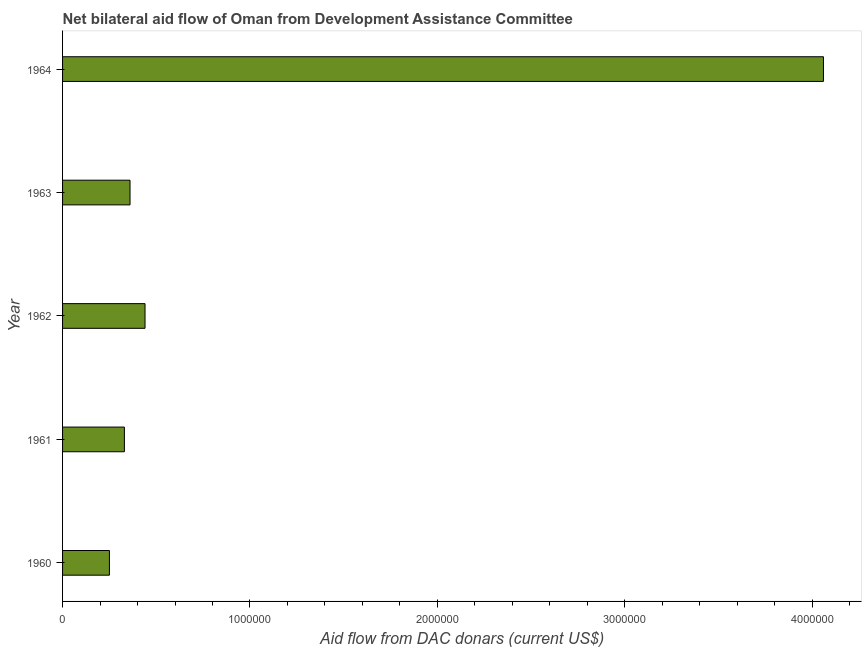Does the graph contain grids?
Provide a short and direct response. No. What is the title of the graph?
Offer a terse response. Net bilateral aid flow of Oman from Development Assistance Committee. What is the label or title of the X-axis?
Keep it short and to the point. Aid flow from DAC donars (current US$). What is the net bilateral aid flows from dac donors in 1964?
Your response must be concise. 4.06e+06. Across all years, what is the maximum net bilateral aid flows from dac donors?
Ensure brevity in your answer.  4.06e+06. In which year was the net bilateral aid flows from dac donors maximum?
Give a very brief answer. 1964. In which year was the net bilateral aid flows from dac donors minimum?
Give a very brief answer. 1960. What is the sum of the net bilateral aid flows from dac donors?
Your answer should be very brief. 5.44e+06. What is the average net bilateral aid flows from dac donors per year?
Make the answer very short. 1.09e+06. What is the median net bilateral aid flows from dac donors?
Ensure brevity in your answer.  3.60e+05. In how many years, is the net bilateral aid flows from dac donors greater than 400000 US$?
Your answer should be very brief. 2. What is the ratio of the net bilateral aid flows from dac donors in 1961 to that in 1962?
Your answer should be compact. 0.75. Is the difference between the net bilateral aid flows from dac donors in 1962 and 1964 greater than the difference between any two years?
Provide a succinct answer. No. What is the difference between the highest and the second highest net bilateral aid flows from dac donors?
Provide a succinct answer. 3.62e+06. Is the sum of the net bilateral aid flows from dac donors in 1963 and 1964 greater than the maximum net bilateral aid flows from dac donors across all years?
Ensure brevity in your answer.  Yes. What is the difference between the highest and the lowest net bilateral aid flows from dac donors?
Offer a very short reply. 3.81e+06. How many bars are there?
Your answer should be compact. 5. Are all the bars in the graph horizontal?
Your answer should be very brief. Yes. How many years are there in the graph?
Keep it short and to the point. 5. What is the Aid flow from DAC donars (current US$) of 1960?
Your answer should be compact. 2.50e+05. What is the Aid flow from DAC donars (current US$) in 1961?
Your answer should be compact. 3.30e+05. What is the Aid flow from DAC donars (current US$) of 1963?
Ensure brevity in your answer.  3.60e+05. What is the Aid flow from DAC donars (current US$) in 1964?
Your answer should be very brief. 4.06e+06. What is the difference between the Aid flow from DAC donars (current US$) in 1960 and 1964?
Give a very brief answer. -3.81e+06. What is the difference between the Aid flow from DAC donars (current US$) in 1961 and 1962?
Offer a terse response. -1.10e+05. What is the difference between the Aid flow from DAC donars (current US$) in 1961 and 1963?
Your answer should be compact. -3.00e+04. What is the difference between the Aid flow from DAC donars (current US$) in 1961 and 1964?
Offer a terse response. -3.73e+06. What is the difference between the Aid flow from DAC donars (current US$) in 1962 and 1964?
Keep it short and to the point. -3.62e+06. What is the difference between the Aid flow from DAC donars (current US$) in 1963 and 1964?
Your answer should be compact. -3.70e+06. What is the ratio of the Aid flow from DAC donars (current US$) in 1960 to that in 1961?
Your answer should be compact. 0.76. What is the ratio of the Aid flow from DAC donars (current US$) in 1960 to that in 1962?
Keep it short and to the point. 0.57. What is the ratio of the Aid flow from DAC donars (current US$) in 1960 to that in 1963?
Keep it short and to the point. 0.69. What is the ratio of the Aid flow from DAC donars (current US$) in 1960 to that in 1964?
Offer a terse response. 0.06. What is the ratio of the Aid flow from DAC donars (current US$) in 1961 to that in 1962?
Your response must be concise. 0.75. What is the ratio of the Aid flow from DAC donars (current US$) in 1961 to that in 1963?
Ensure brevity in your answer.  0.92. What is the ratio of the Aid flow from DAC donars (current US$) in 1961 to that in 1964?
Make the answer very short. 0.08. What is the ratio of the Aid flow from DAC donars (current US$) in 1962 to that in 1963?
Your answer should be very brief. 1.22. What is the ratio of the Aid flow from DAC donars (current US$) in 1962 to that in 1964?
Your answer should be compact. 0.11. What is the ratio of the Aid flow from DAC donars (current US$) in 1963 to that in 1964?
Provide a succinct answer. 0.09. 